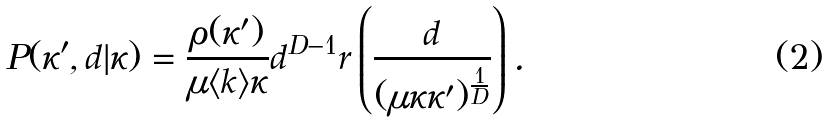Convert formula to latex. <formula><loc_0><loc_0><loc_500><loc_500>P ( \kappa ^ { \prime } , d | \kappa ) = \frac { \rho ( \kappa ^ { \prime } ) } { \mu \langle k \rangle \kappa } d ^ { D - 1 } r \left ( \frac { d } { ( \mu \kappa \kappa ^ { \prime } ) ^ { \frac { 1 } { D } } } \right ) .</formula> 